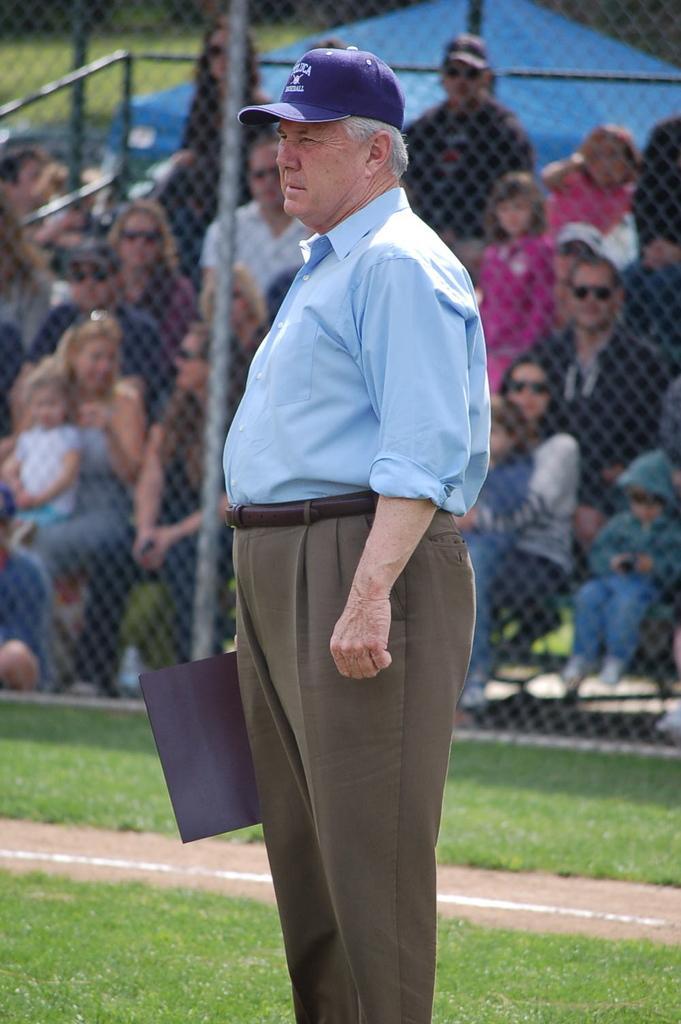Please provide a concise description of this image. In this picture we can observe a man standing in the ground holding black color board in his hand. We can observe violet color cap on the head of this person. In the background we can observe fence and some people sitting in the chairs. There are men and women in this picture. 